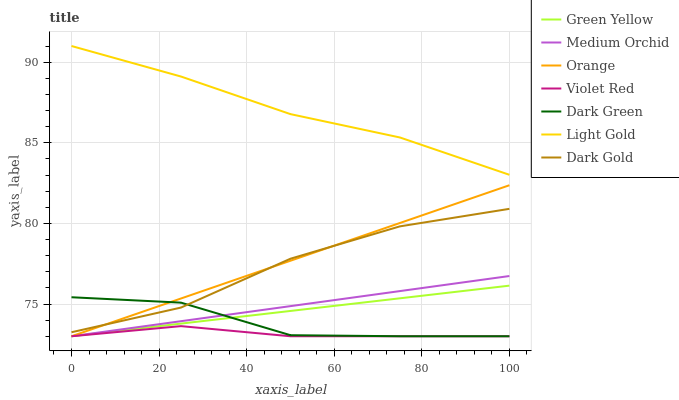Does Violet Red have the minimum area under the curve?
Answer yes or no. Yes. Does Light Gold have the maximum area under the curve?
Answer yes or no. Yes. Does Dark Gold have the minimum area under the curve?
Answer yes or no. No. Does Dark Gold have the maximum area under the curve?
Answer yes or no. No. Is Orange the smoothest?
Answer yes or no. Yes. Is Dark Green the roughest?
Answer yes or no. Yes. Is Dark Gold the smoothest?
Answer yes or no. No. Is Dark Gold the roughest?
Answer yes or no. No. Does Violet Red have the lowest value?
Answer yes or no. Yes. Does Dark Gold have the lowest value?
Answer yes or no. No. Does Light Gold have the highest value?
Answer yes or no. Yes. Does Dark Gold have the highest value?
Answer yes or no. No. Is Dark Green less than Light Gold?
Answer yes or no. Yes. Is Light Gold greater than Green Yellow?
Answer yes or no. Yes. Does Dark Green intersect Violet Red?
Answer yes or no. Yes. Is Dark Green less than Violet Red?
Answer yes or no. No. Is Dark Green greater than Violet Red?
Answer yes or no. No. Does Dark Green intersect Light Gold?
Answer yes or no. No. 